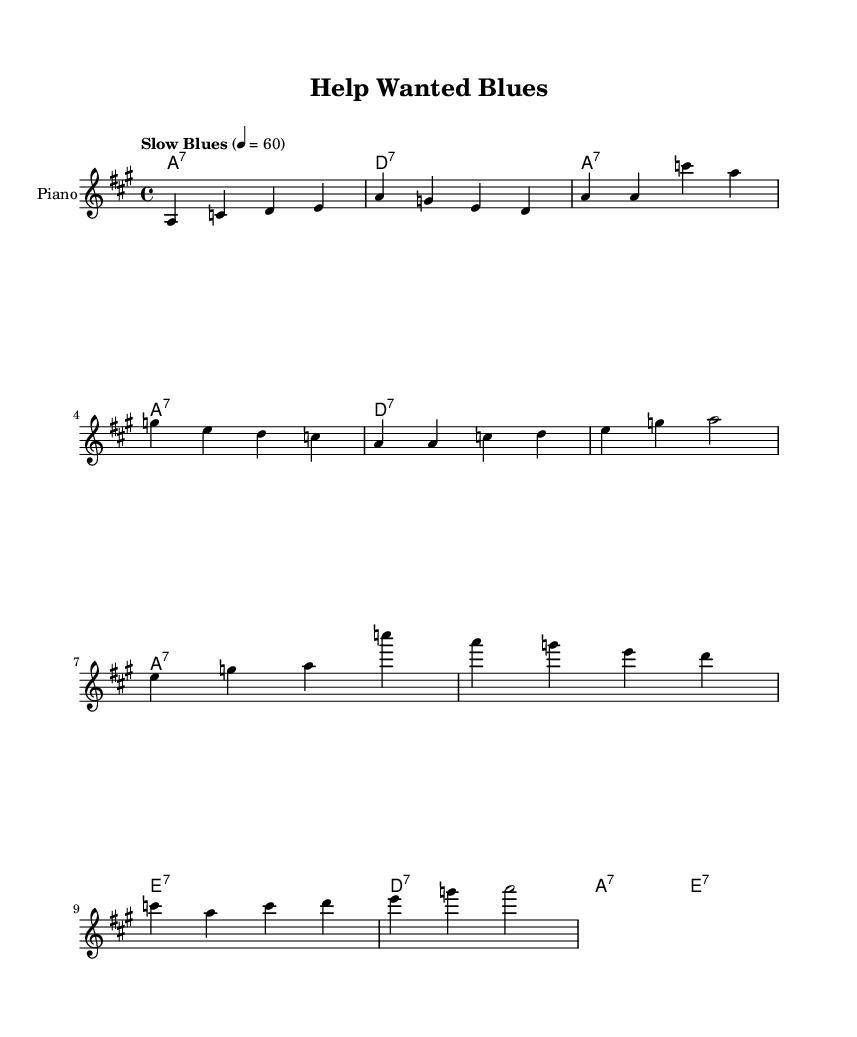What is the key signature of this music? The key signature shown in the sheet music indicates the scale that the piece is based on. In this example, the key signature is A major, which typically has three sharps (F#, C#, and G#). However, it's important to note that no sharps or flats appear alongside the staff, indicating the presence of A major.
Answer: A major What is the time signature of this piece? The time signature in the provided music indicates how many beats are in each measure. Here, 4/4 is displayed, meaning there are four beats per measure, and each quarter note receives one beat. This is a common time signature in many music styles, including Blues.
Answer: 4/4 What tempo is marked in the score? The tempo marked in the sheet music provides guidance on how fast or slow the piece should be played. Here, it indicates "Slow Blues," with a metronome marking of 60 beats per minute. It suggests a relaxed and laid-back feel typical of Blues music.
Answer: Slow Blues What is the structure of the song? The song's structure can be understood by identifying distinct sections in the sheet music. This piece consists of an introduction, followed by verses, and then a repeating chorus that reinforces the central theme. Understanding this structure is key to performing the piece correctly.
Answer: Intro, Verse, Chorus How many measures are in the verse? To find out how many measures are in the verse, one must count the separate segments of music that were defined within the bar lines. In this case, the verse section spans over four measures indicated in the written score. This is vital for knowing how to divide the lyrics for performance.
Answer: Four measures What is the overall theme of the lyrics? Analyzing the lyrics presented in the music reveals a narrative. The lyrics describe the struggles of searching for a trustworthy employee, showcasing feelings of frustration and determination. This thematic element is commonly found in Blues music, which often expresses personal or professional hardships.
Answer: Trustworthy employee 